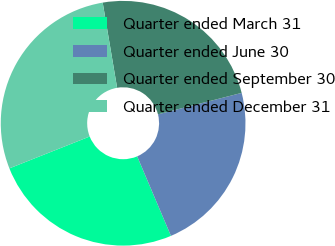<chart> <loc_0><loc_0><loc_500><loc_500><pie_chart><fcel>Quarter ended March 31<fcel>Quarter ended June 30<fcel>Quarter ended September 30<fcel>Quarter ended December 31<nl><fcel>25.38%<fcel>22.6%<fcel>23.68%<fcel>28.34%<nl></chart> 